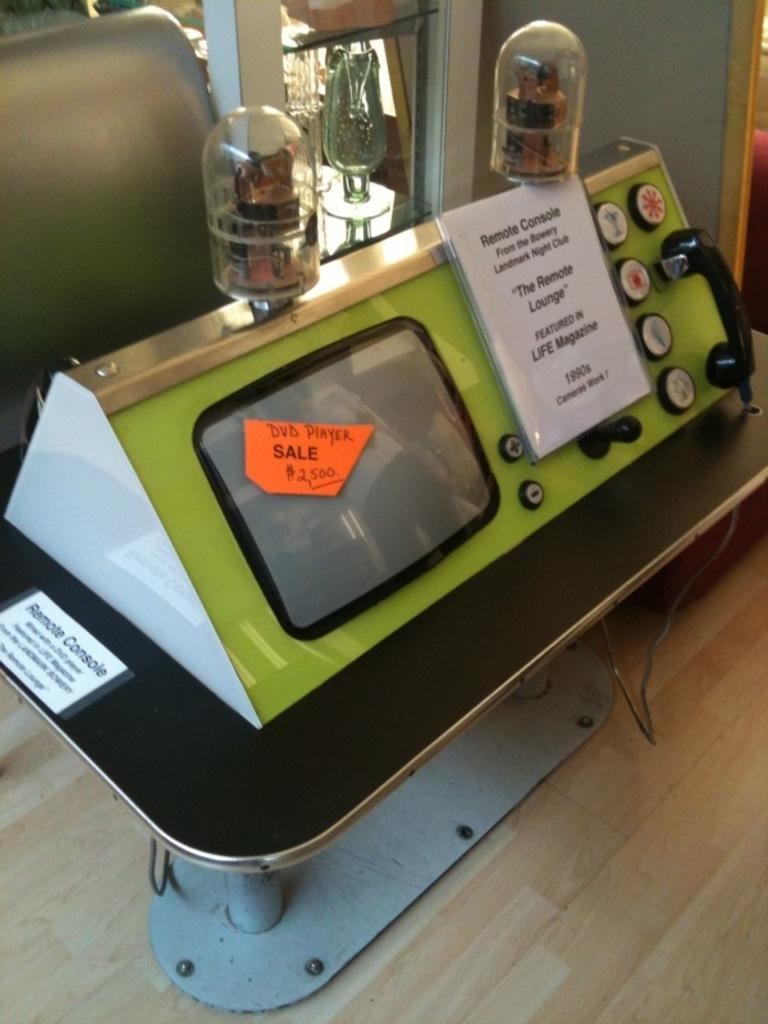What type of electric object is present in the image? There is an electric object in the image, but the specific type cannot be determined from the provided facts. How many bulbs are on the electric object? The electric object has two bulbs on it. Are there any bushes or giants visible in the image? There is no mention of bushes or giants in the provided facts, so we cannot determine their presence in the image. 